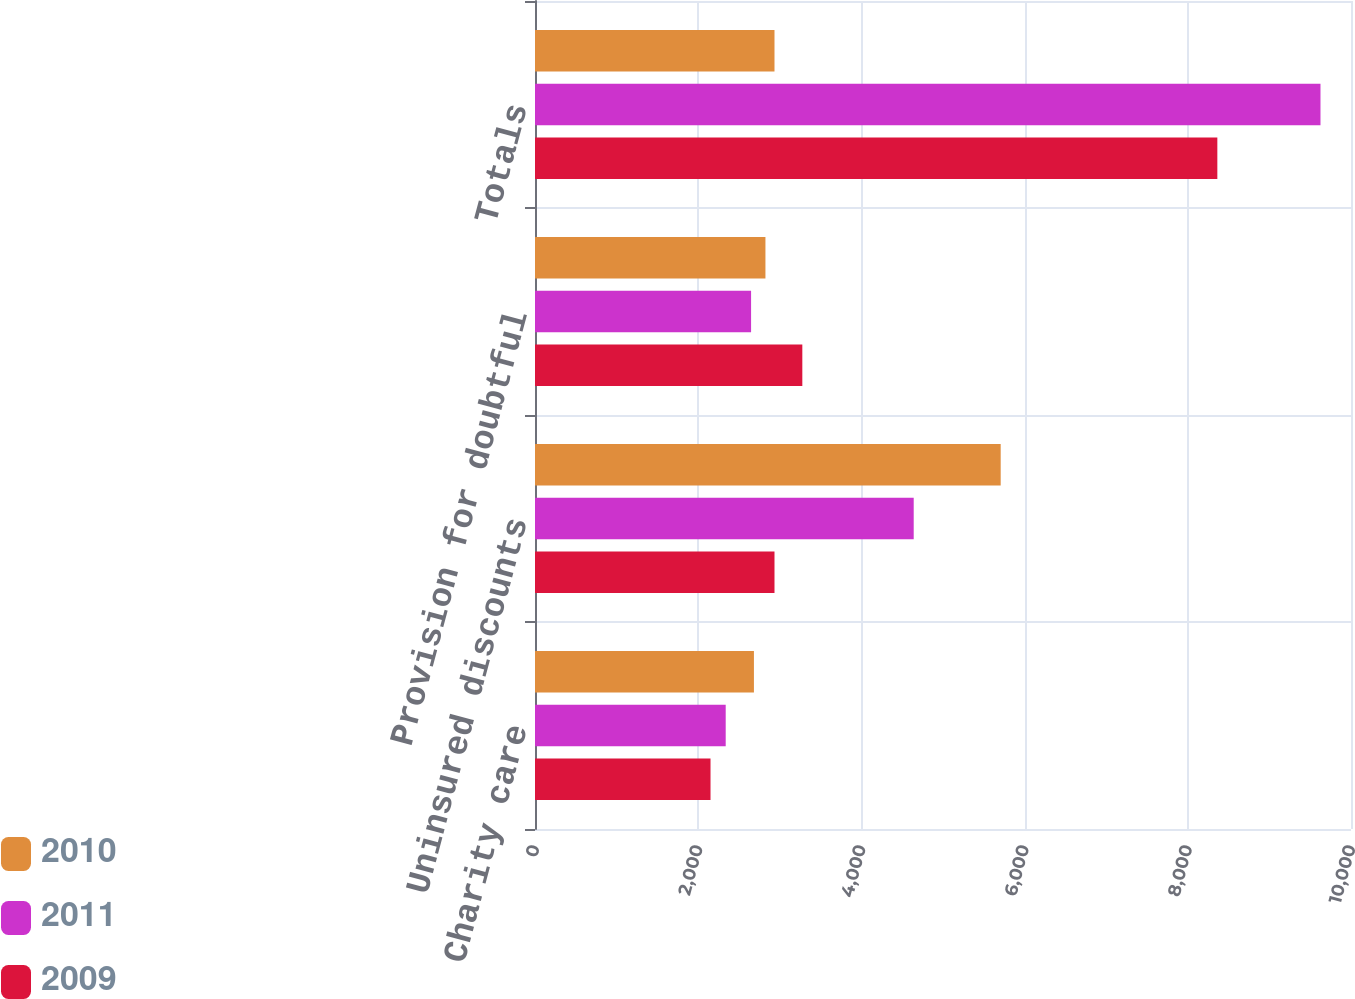<chart> <loc_0><loc_0><loc_500><loc_500><stacked_bar_chart><ecel><fcel>Charity care<fcel>Uninsured discounts<fcel>Provision for doubtful<fcel>Totals<nl><fcel>2010<fcel>2683<fcel>5707<fcel>2824<fcel>2935<nl><fcel>2011<fcel>2337<fcel>4641<fcel>2648<fcel>9626<nl><fcel>2009<fcel>2151<fcel>2935<fcel>3276<fcel>8362<nl></chart> 